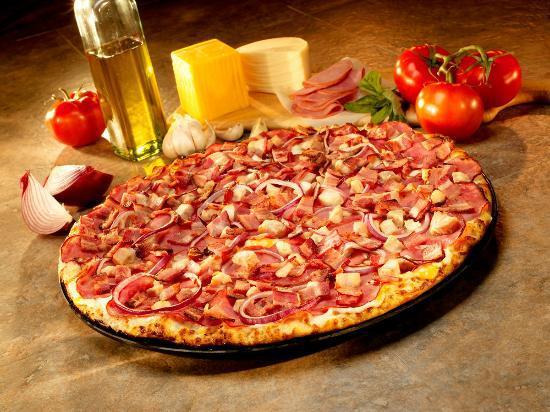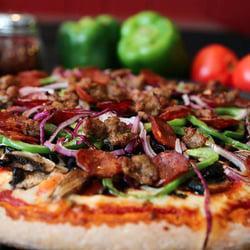The first image is the image on the left, the second image is the image on the right. Given the left and right images, does the statement "One of the pizzas is a cheese and pepperoni pizza." hold true? Answer yes or no. No. The first image is the image on the left, the second image is the image on the right. Given the left and right images, does the statement "There is at least one [basil] leaf on the pizza on the right." hold true? Answer yes or no. No. 